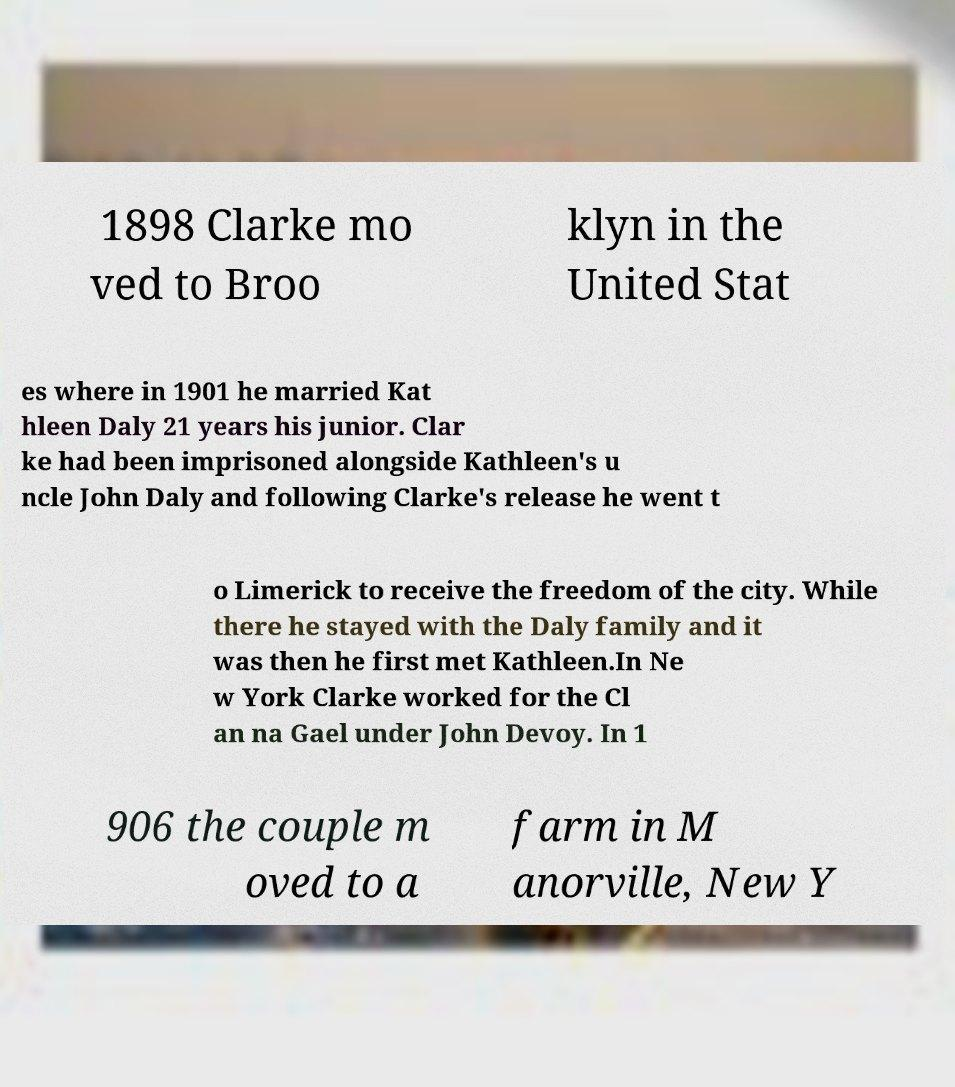What messages or text are displayed in this image? I need them in a readable, typed format. 1898 Clarke mo ved to Broo klyn in the United Stat es where in 1901 he married Kat hleen Daly 21 years his junior. Clar ke had been imprisoned alongside Kathleen's u ncle John Daly and following Clarke's release he went t o Limerick to receive the freedom of the city. While there he stayed with the Daly family and it was then he first met Kathleen.In Ne w York Clarke worked for the Cl an na Gael under John Devoy. In 1 906 the couple m oved to a farm in M anorville, New Y 